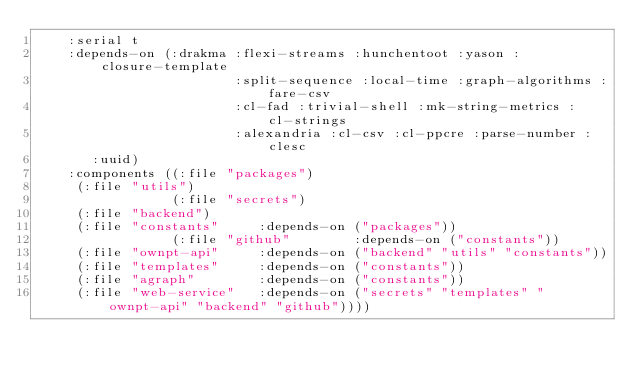Convert code to text. <code><loc_0><loc_0><loc_500><loc_500><_Lisp_>    :serial t
    :depends-on (:drakma :flexi-streams :hunchentoot :yason :closure-template
                         :split-sequence :local-time :graph-algorithms :fare-csv
                         :cl-fad :trivial-shell :mk-string-metrics :cl-strings
                         :alexandria :cl-csv :cl-ppcre :parse-number :clesc
			 :uuid)
    :components ((:file "packages")
		 (:file "utils")
                 (:file "secrets")
		 (:file "backend")
		 (:file "constants"     :depends-on ("packages"))
                 (:file "github"        :depends-on ("constants"))
		 (:file "ownpt-api"     :depends-on ("backend" "utils" "constants"))
		 (:file "templates"     :depends-on ("constants"))
		 (:file "agraph"        :depends-on ("constants"))
		 (:file "web-service"   :depends-on ("secrets" "templates" "ownpt-api" "backend" "github"))))
</code> 